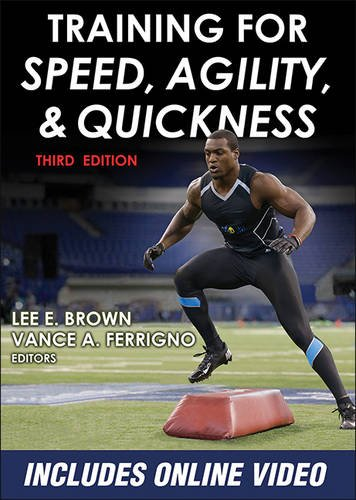Is this a Christianity book? No, this book is unrelated to Christianity; it focuses entirely on athletic training and physical conditioning. 